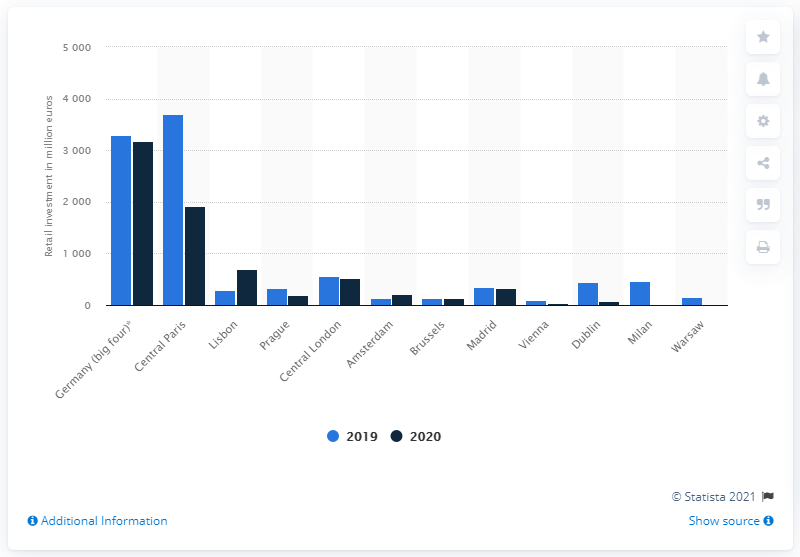List a handful of essential elements in this visual. In 2020, Berlin, Hamburg, Munich, and Frankfurt collectively received a total investment of 3,183... 